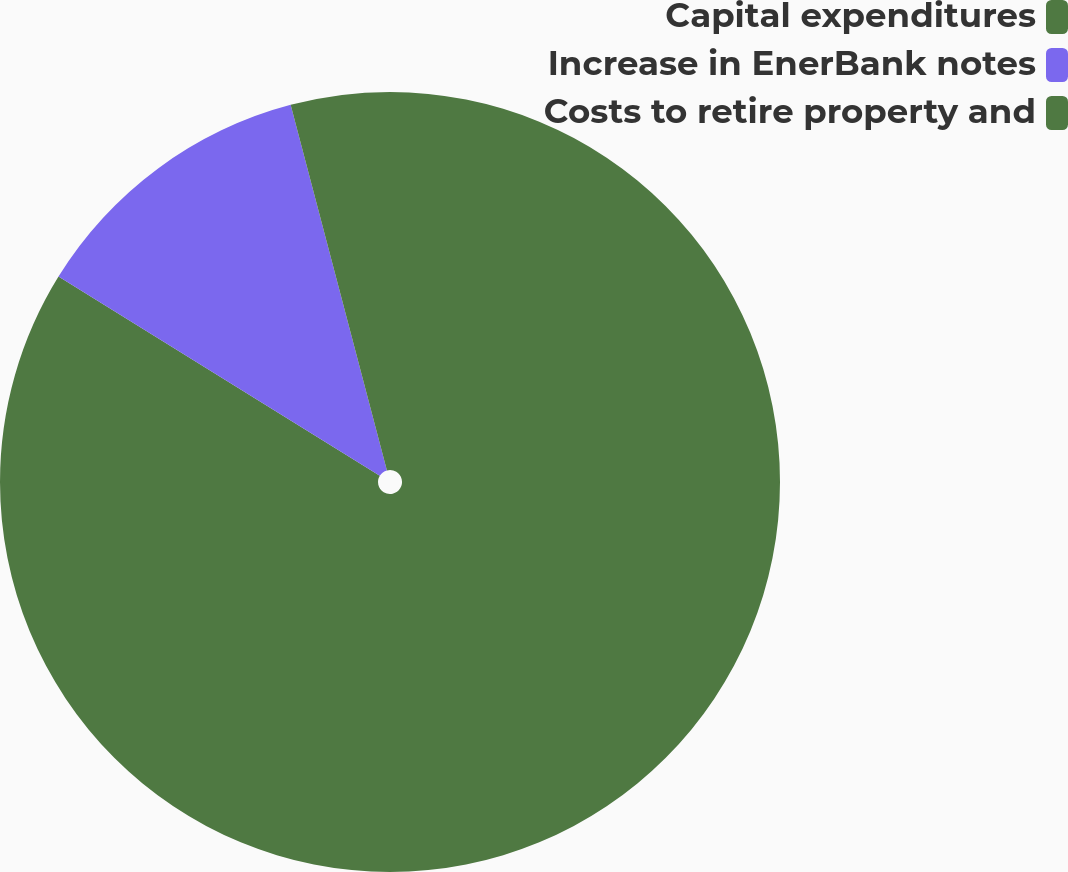Convert chart. <chart><loc_0><loc_0><loc_500><loc_500><pie_chart><fcel>Capital expenditures<fcel>Increase in EnerBank notes<fcel>Costs to retire property and<nl><fcel>83.83%<fcel>12.07%<fcel>4.1%<nl></chart> 